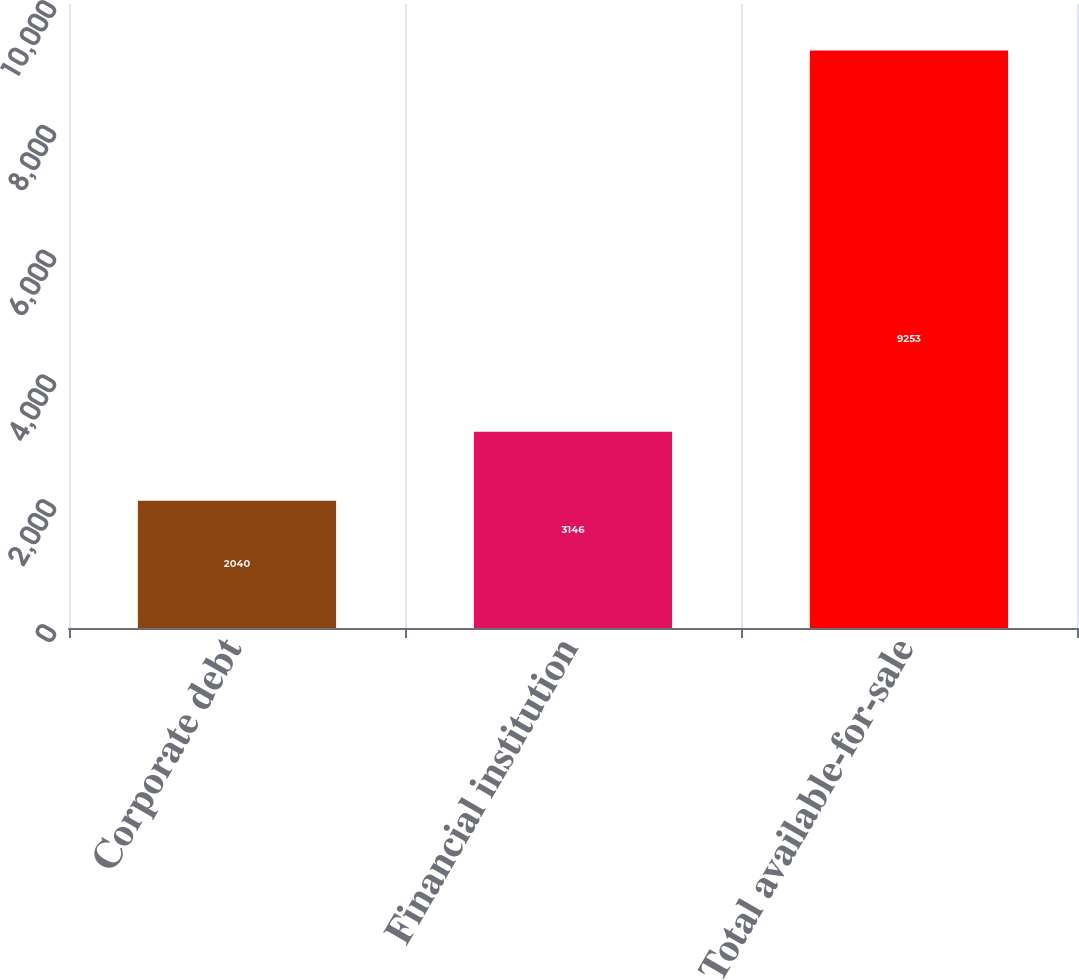Convert chart. <chart><loc_0><loc_0><loc_500><loc_500><bar_chart><fcel>Corporate debt<fcel>Financial institution<fcel>Total available-for-sale<nl><fcel>2040<fcel>3146<fcel>9253<nl></chart> 